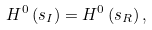<formula> <loc_0><loc_0><loc_500><loc_500>H ^ { 0 } \left ( s _ { I } \right ) = H ^ { 0 } \left ( s _ { R } \right ) ,</formula> 